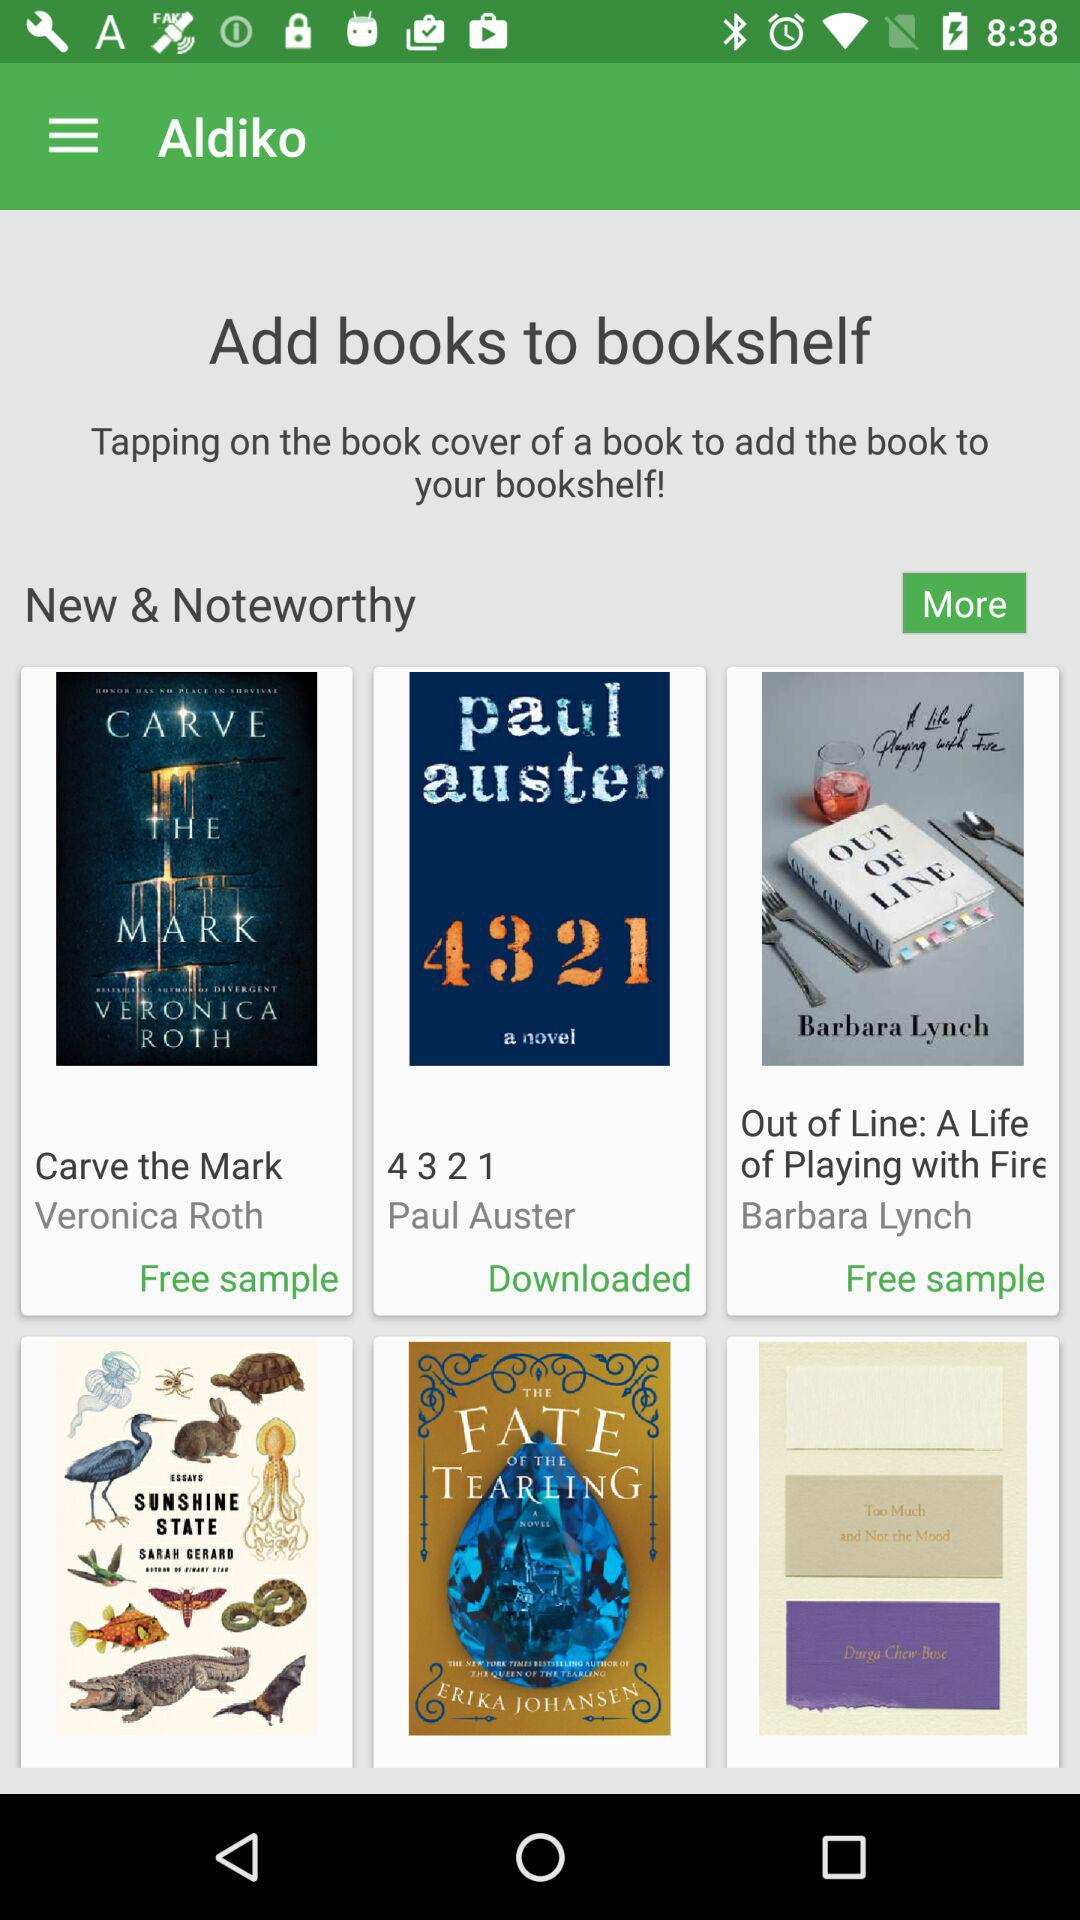How many books are on the bookshelf?
When the provided information is insufficient, respond with <no answer>. <no answer> 